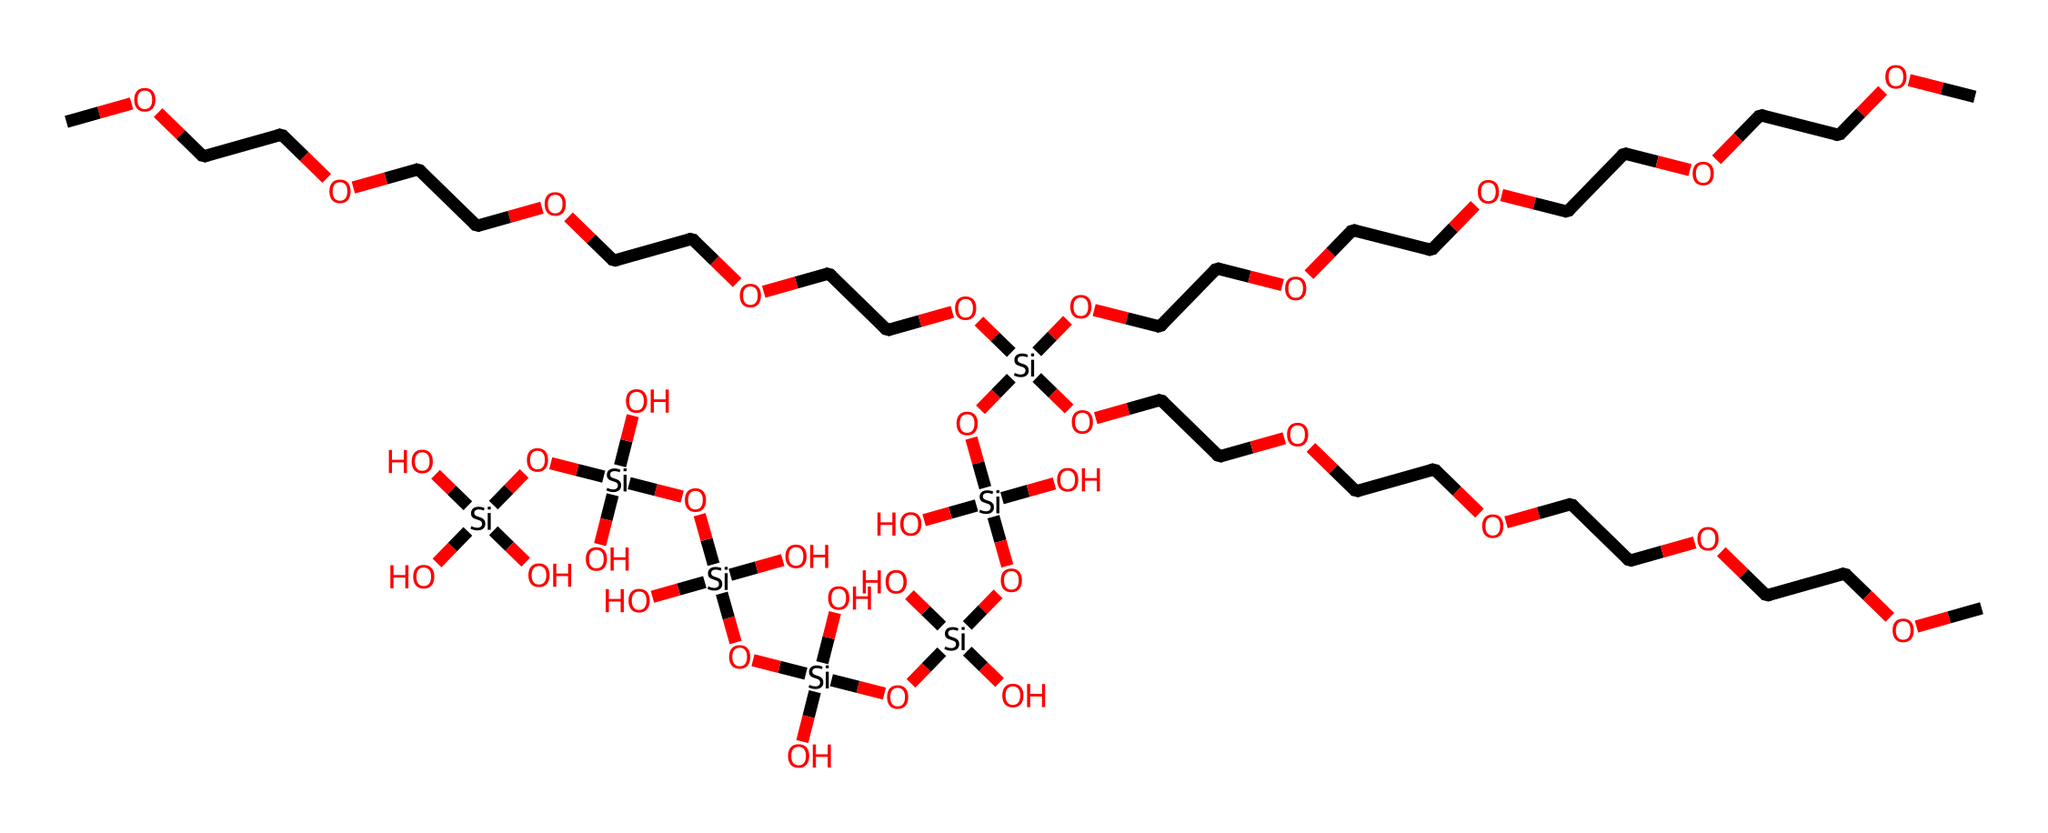What is the core structural element of this chemical? The core structural element is the silicon atom, which can be identified as the central atom around which the other elements are arranged in the siloxane bonds.
Answer: silicon How many hydroxyl groups are present in the structure? By examining the structure, there are several -OH groups (hydroxyl) attached to the silica units. Counting them gives a total of seven hydroxyl groups.
Answer: seven What type of bonds connect the silicon atoms in this chemical? The silicon atoms are connected primarily by siloxane bonds (Si-O-Si bonds), which are characteristic of silicates, indicating that they form a network structure through these covalent bonds.
Answer: siloxane bonds What is the main polymer present in this chemical structure? The chemical includes polyethylene glycol (PEG) as indicated by the repeating ether groups and carbon backbone. This is evidenced by the presence of the ethylene glycol segments interspersed with the silicon chains.
Answer: polyethylene glycol How does the presence of silica nanoparticles affect the viscosity of this polymeric material? The incorporation of silica nanoparticles into polyethylene glycol creates a non-Newtonian fluid, where viscosity changes with the applied stress or shear rate, likely increasing the viscosity because silica enhances structural integrity and alters flow characteristics.
Answer: increases viscosity What role do hydroxyl groups play in the properties of this structure? Hydroxyl groups in the structure contribute to hydrophilicity and increase the interaction with water, impacting the overall solubility and stability of the nanoparticles within the polymeric matrix.
Answer: hydrophilicity 